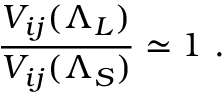<formula> <loc_0><loc_0><loc_500><loc_500>\frac { V _ { i j } ( \Lambda _ { L } ) } { V _ { i j } ( \Lambda _ { S } ) } \simeq 1 \ .</formula> 